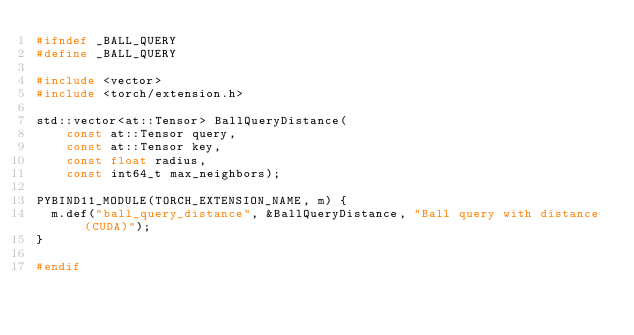<code> <loc_0><loc_0><loc_500><loc_500><_C++_>#ifndef _BALL_QUERY
#define _BALL_QUERY

#include <vector>
#include <torch/extension.h>

std::vector<at::Tensor> BallQueryDistance(
    const at::Tensor query,
    const at::Tensor key,
    const float radius,
    const int64_t max_neighbors);

PYBIND11_MODULE(TORCH_EXTENSION_NAME, m) {
  m.def("ball_query_distance", &BallQueryDistance, "Ball query with distance (CUDA)");
}

#endif</code> 